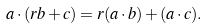Convert formula to latex. <formula><loc_0><loc_0><loc_500><loc_500>a \cdot ( r b + c ) = r ( a \cdot b ) + ( a \cdot c ) .</formula> 